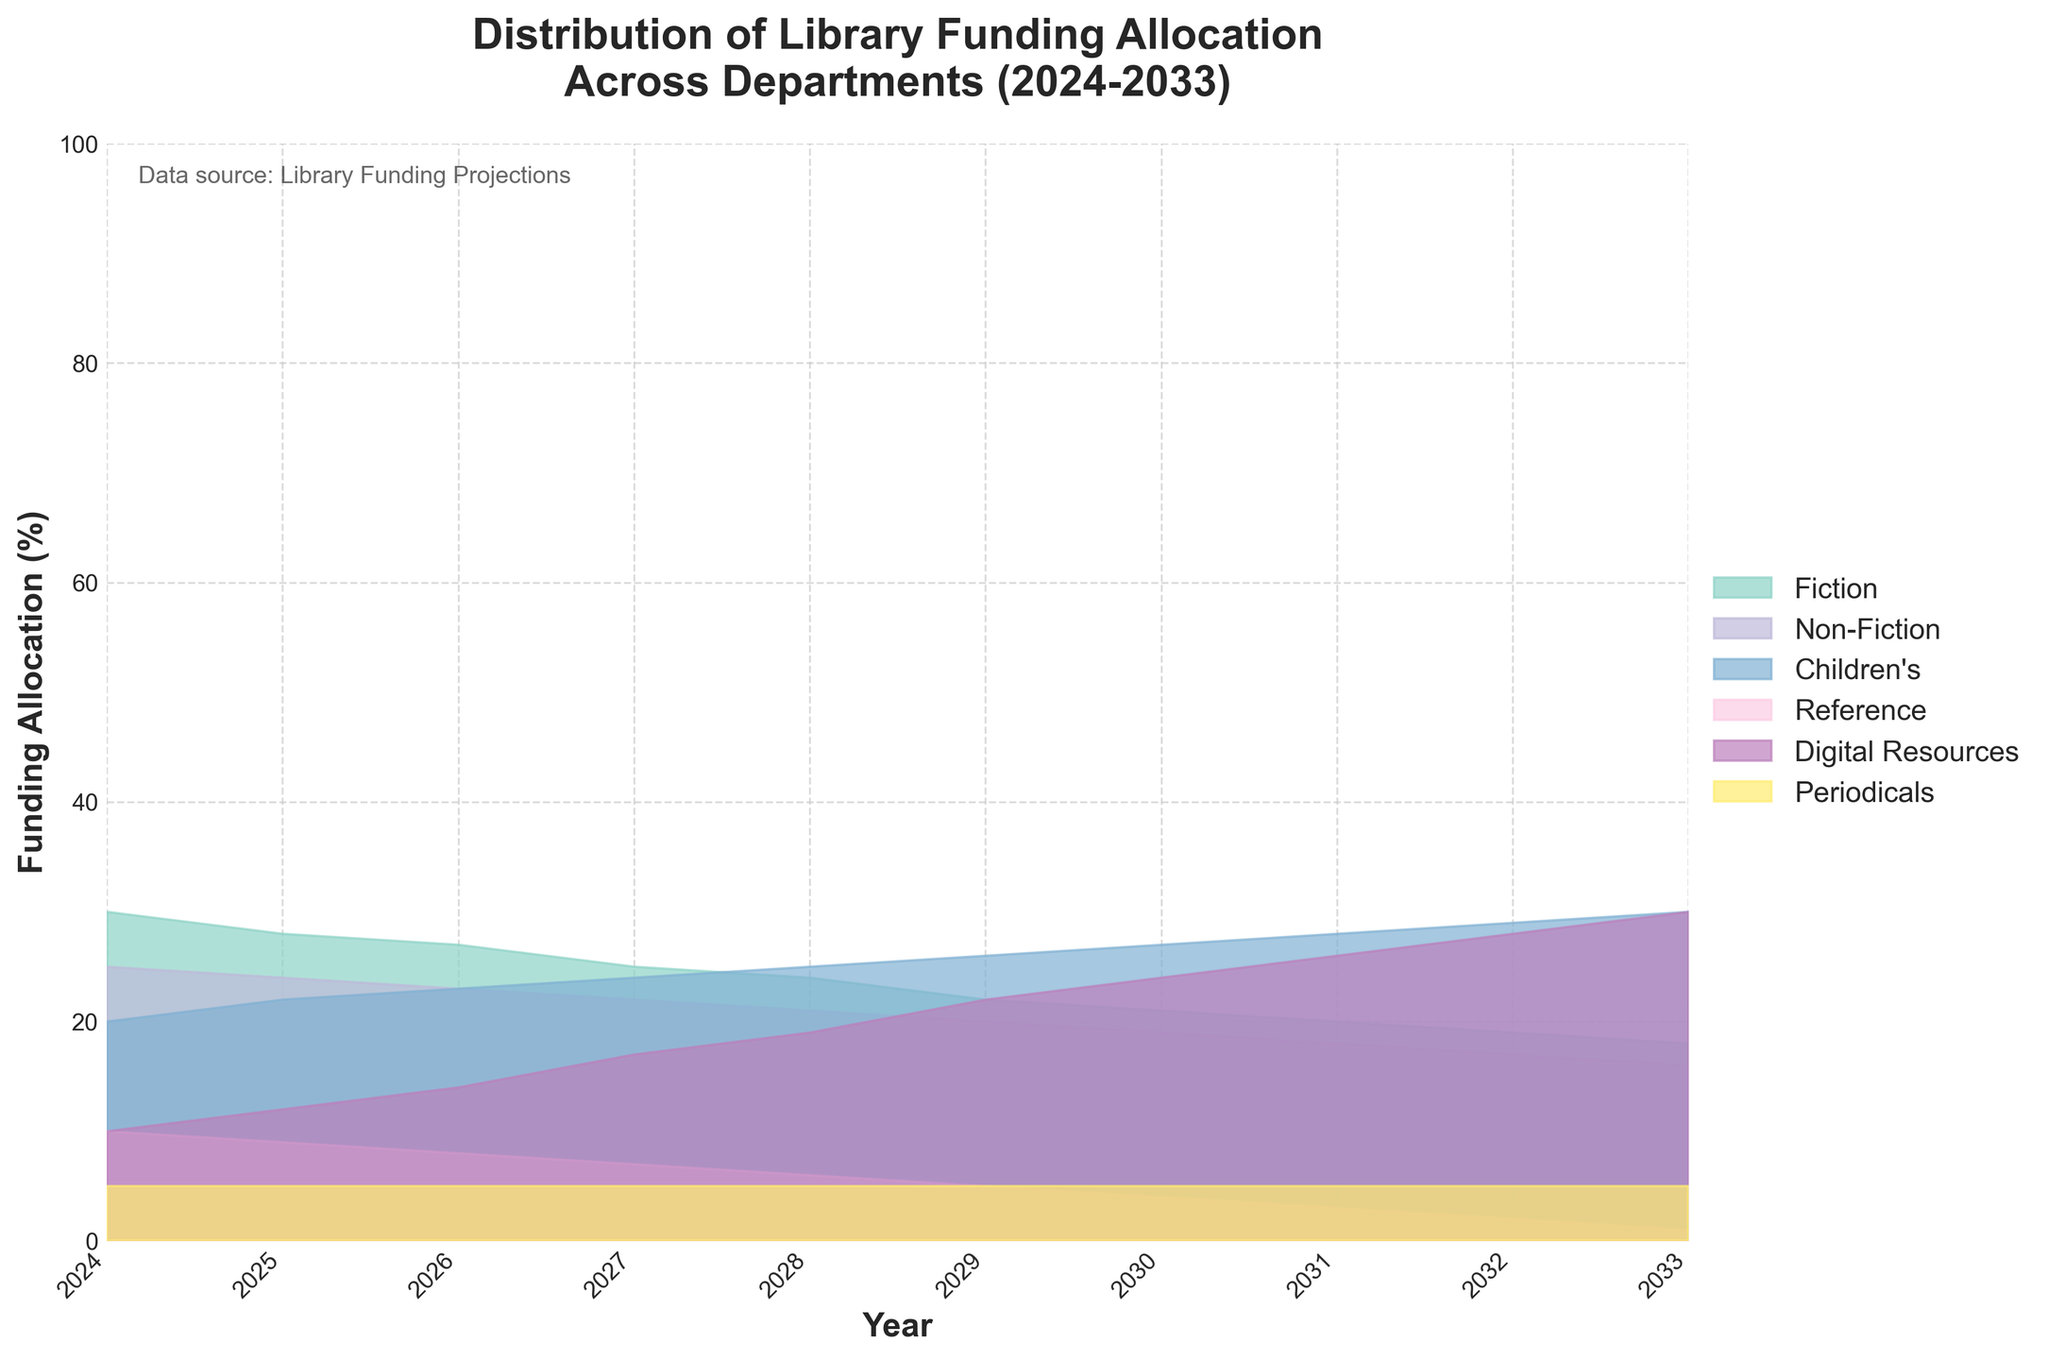what's the range of years displayed in the figure? The range of years displayed in the figure can be seen on the x-axis, which starts at 2024 and ends at 2033.
Answer: 2024 to 2033 what's the funding allocation percentage for Fiction in 2030? The plot shows the allocation percentages for each category per year. For Fiction in 2030, the funding allocation is represented at the point where the Fiction category line intersects the vertical line at 2030.
Answer: 21% which department sees the most significant increase in funding allocation over the decade? To determine the department with the most significant increase, check the rate of change of the percentage allocation from 2024 to 2033 for each department. The Digital Resources category moves from 10% to 30%, which is the largest increase.
Answer: Digital Resources what's the difference in funding allocation between Children's and Reference departments in 2028? In 2028, the Children's department is allocated 25%, and the Reference department is allocated 6%. The difference between these values is 25% - 6%.
Answer: 19% which department's funding allocation remains constant throughout the decade, and what is the constant value? Look for a category where the funding allocation percentage does not change from year to year. The Periodicals department has a constant allocation of 5% throughout the decade.
Answer: Periodicals, 5% how does the funding allocation for Non-Fiction change from 2024 to 2027? The Non-Fiction department starts at 25% in 2024. By 2027, its allocation decreases to 22%. The change is 25% - 22%.
Answer: 3% decrease what's the funding allocation percentage for Digital Resources in 2025 and 2030? The plot shows the percentages along the vertical line for each year. For Digital Resources, it shows 12% in 2025 and 24% in 2030.
Answer: 12% in 2025, 24% in 2030 which two departments have the same funding allocation in 2025, and what is that percentage? In 2025, the allocation lines for Fiction and Non-Fiction both intersect the vertical line at 2025 at around 24%.
Answer: Fiction and Non-Fiction, 24% what is the total funding allocation percentage for Children's and Digital Resources combined in 2027? In 2027, Children's is allocated 24%, and Digital Resources 17%. The combined allocation is 24% + 17%.
Answer: 41% what is the trend for Reference department funding allocation over the decade? The allocation for the Reference department starts at 10% in 2024 and gradually reduces to 1% by 2033. This indicates a declining trend.
Answer: Declining 